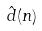Convert formula to latex. <formula><loc_0><loc_0><loc_500><loc_500>\hat { d } ( n )</formula> 